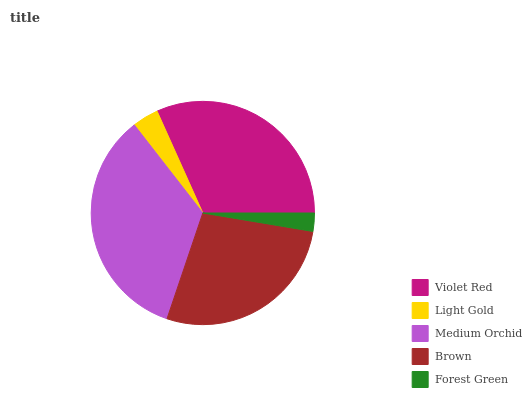Is Forest Green the minimum?
Answer yes or no. Yes. Is Medium Orchid the maximum?
Answer yes or no. Yes. Is Light Gold the minimum?
Answer yes or no. No. Is Light Gold the maximum?
Answer yes or no. No. Is Violet Red greater than Light Gold?
Answer yes or no. Yes. Is Light Gold less than Violet Red?
Answer yes or no. Yes. Is Light Gold greater than Violet Red?
Answer yes or no. No. Is Violet Red less than Light Gold?
Answer yes or no. No. Is Brown the high median?
Answer yes or no. Yes. Is Brown the low median?
Answer yes or no. Yes. Is Medium Orchid the high median?
Answer yes or no. No. Is Violet Red the low median?
Answer yes or no. No. 